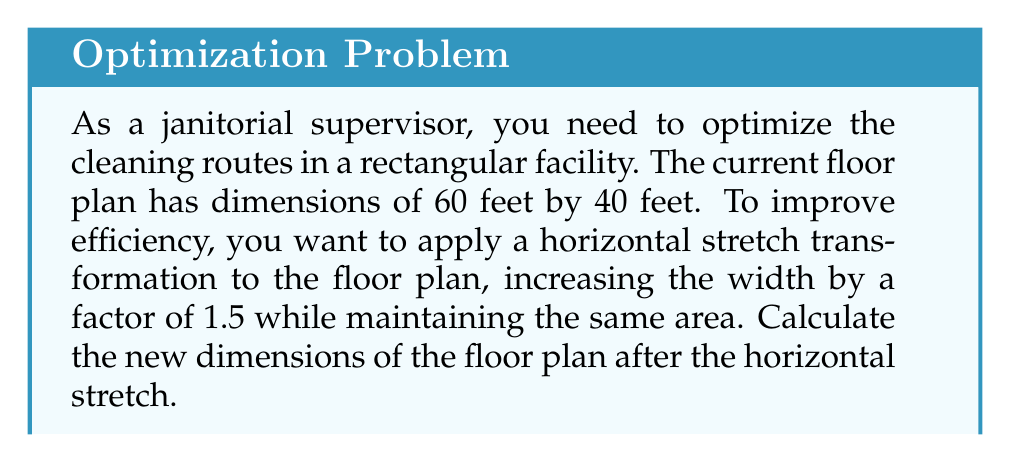Show me your answer to this math problem. Let's approach this step-by-step:

1) First, let's define our variables:
   Original width: $w = 60$ feet
   Original length: $l = 40$ feet
   Stretch factor: $k = 1.5$

2) The horizontal stretch will affect the width of the floor plan:
   New width: $w_{new} = kw = 1.5 \times 60 = 90$ feet

3) We need to maintain the same area, so:
   Original area = New area
   $w \times l = w_{new} \times l_{new}$

4) Substitute the known values:
   $60 \times 40 = 90 \times l_{new}$

5) Solve for $l_{new}$:
   $$l_{new} = \frac{60 \times 40}{90} = \frac{2400}{90} = \frac{80}{3} \approx 26.67$$

6) Therefore, the new dimensions are:
   Width: 90 feet
   Length: $\frac{80}{3}$ feet (or approximately 26.67 feet)

We can verify that the area remains the same:
Original area: $60 \times 40 = 2400$ sq ft
New area: $90 \times \frac{80}{3} = 2400$ sq ft
Answer: The new dimensions of the floor plan after the horizontal stretch are 90 feet wide by $\frac{80}{3}$ feet long (approximately 90 feet by 26.67 feet). 